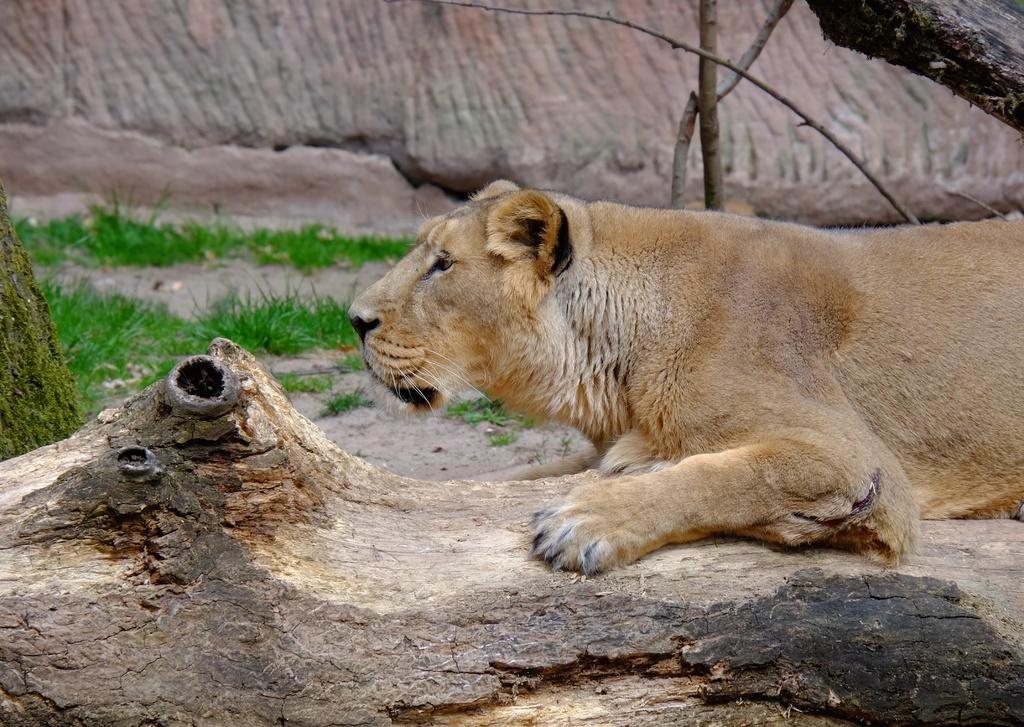Describe this image in one or two sentences. In this picture we can see a tiger on the wooden bark, beside to the tiger we can see grass. 